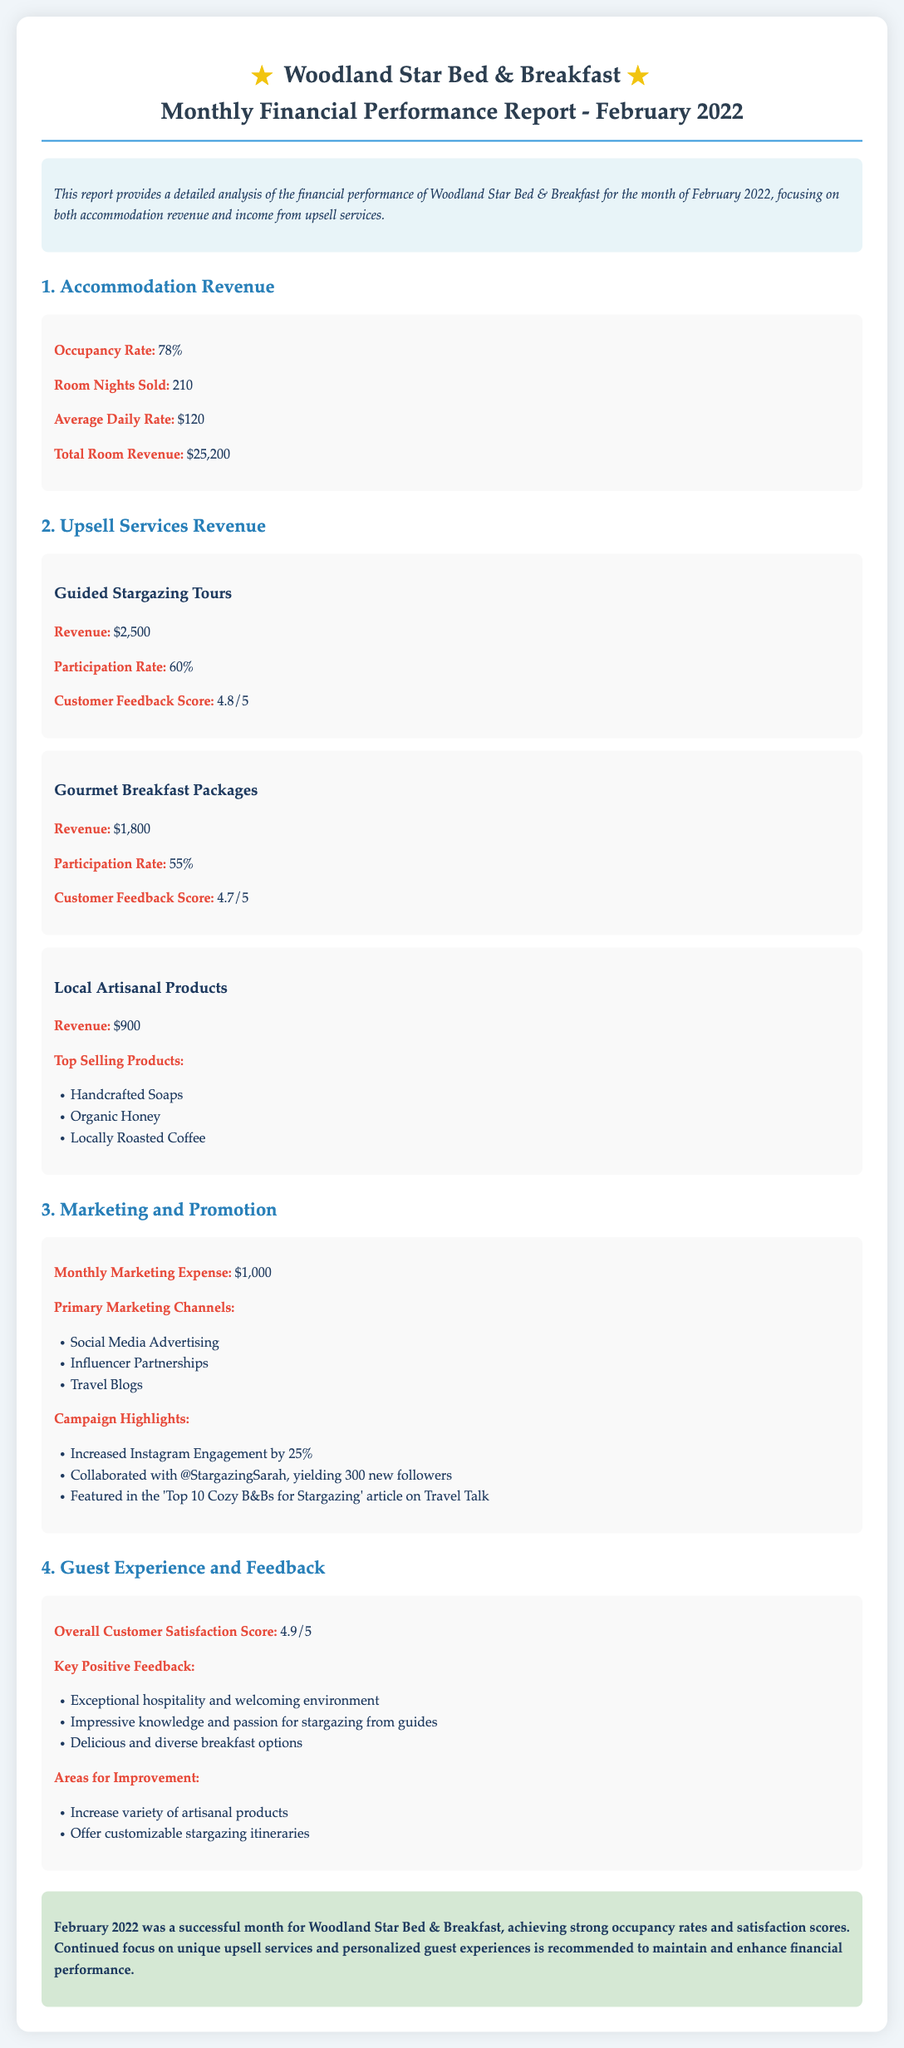What was the occupancy rate in February 2022? The occupancy rate is specifically mentioned in the document and is noted as 78%.
Answer: 78% What is the total room revenue for February 2022? The total room revenue is clearly stated as $25,200 in the document.
Answer: $25,200 How much revenue was generated from guided stargazing tours? The document specifies the revenue from guided stargazing tours as $2,500.
Answer: $2,500 What was the customer feedback score for the gourmet breakfast packages? The document lists the customer feedback score for gourmet breakfast packages as 4.7 out of 5.
Answer: 4.7/5 What is the primary marketing channel mentioned in the report? The report outlines several marketing channels, with social media advertising being one of the primary ones.
Answer: Social Media Advertising How many room nights were sold in February 2022? The number of room nights sold is explicitly stated in the document as 210.
Answer: 210 What was the overall customer satisfaction score? The overall customer satisfaction score is given in the document as 4.9 out of 5.
Answer: 4.9/5 What areas for improvement are suggested in the document? The areas for improvement mentioned include increasing variety of artisanal products and offering customizable stargazing itineraries.
Answer: Increase variety of artisanal products; Offer customizable stargazing itineraries How much was spent on monthly marketing expenses? The document specifies the monthly marketing expense as $1,000.
Answer: $1,000 What is the total revenue from upsell services? The total revenue from upsell services is the sum of all upsell services listed in the document, which is $2,500 + $1,800 + $900 = $5,200.
Answer: $5,200 